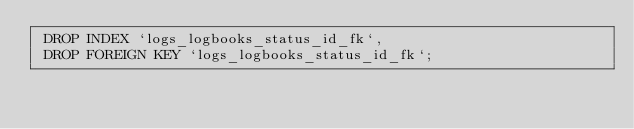Convert code to text. <code><loc_0><loc_0><loc_500><loc_500><_SQL_> DROP INDEX `logs_logbooks_status_id_fk`,
 DROP FOREIGN KEY `logs_logbooks_status_id_fk`;</code> 